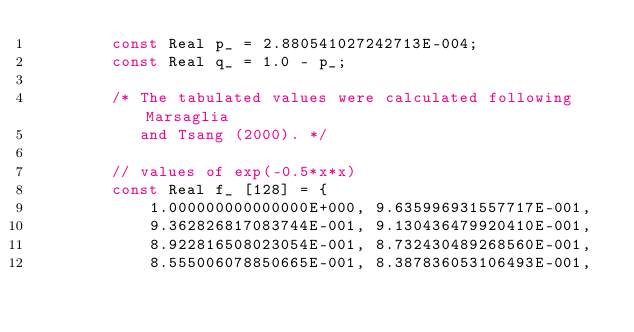<code> <loc_0><loc_0><loc_500><loc_500><_C++_>        const Real p_ = 2.880541027242713E-004;
        const Real q_ = 1.0 - p_;

        /* The tabulated values were calculated following Marsaglia
           and Tsang (2000). */

        // values of exp(-0.5*x*x)
        const Real f_ [128] = {
            1.000000000000000E+000, 9.635996931557717E-001,
            9.362826817083744E-001, 9.130436479920410E-001,
            8.922816508023054E-001, 8.732430489268560E-001,
            8.555006078850665E-001, 8.387836053106493E-001,</code> 